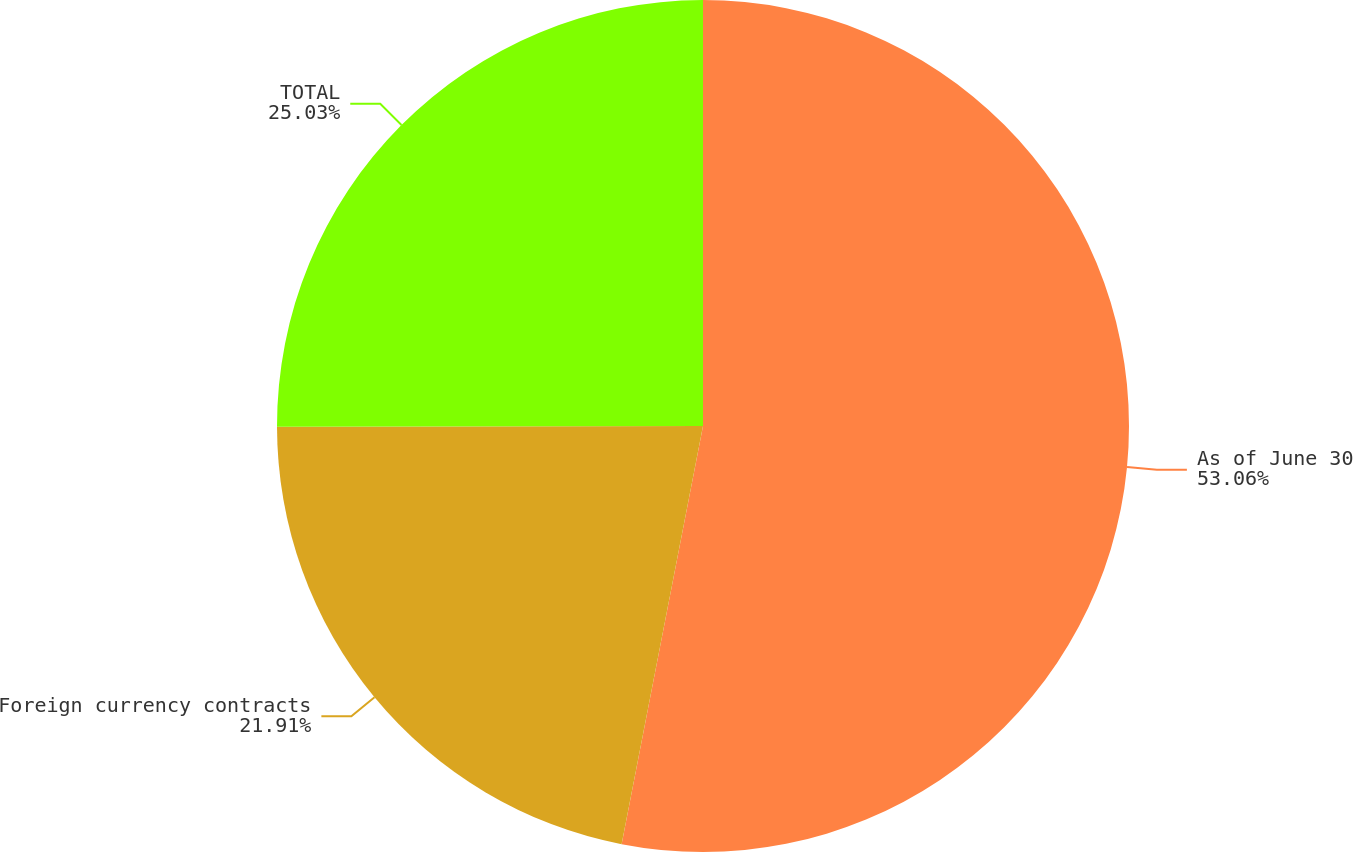<chart> <loc_0><loc_0><loc_500><loc_500><pie_chart><fcel>As of June 30<fcel>Foreign currency contracts<fcel>TOTAL<nl><fcel>53.06%<fcel>21.91%<fcel>25.03%<nl></chart> 